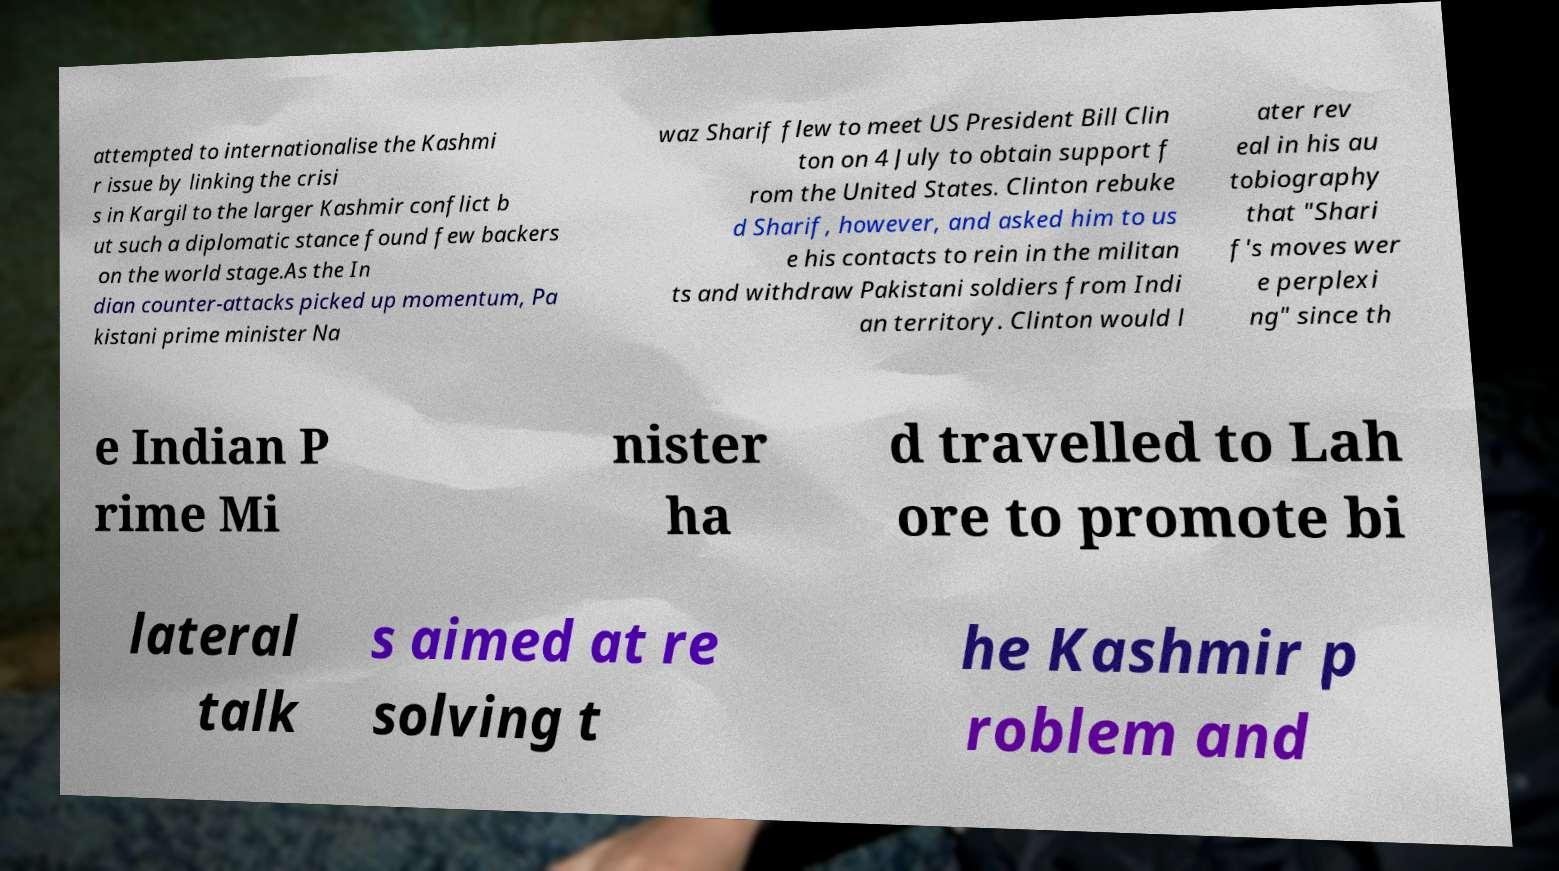Can you read and provide the text displayed in the image?This photo seems to have some interesting text. Can you extract and type it out for me? attempted to internationalise the Kashmi r issue by linking the crisi s in Kargil to the larger Kashmir conflict b ut such a diplomatic stance found few backers on the world stage.As the In dian counter-attacks picked up momentum, Pa kistani prime minister Na waz Sharif flew to meet US President Bill Clin ton on 4 July to obtain support f rom the United States. Clinton rebuke d Sharif, however, and asked him to us e his contacts to rein in the militan ts and withdraw Pakistani soldiers from Indi an territory. Clinton would l ater rev eal in his au tobiography that "Shari f's moves wer e perplexi ng" since th e Indian P rime Mi nister ha d travelled to Lah ore to promote bi lateral talk s aimed at re solving t he Kashmir p roblem and 